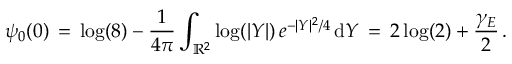<formula> <loc_0><loc_0><loc_500><loc_500>\psi _ { 0 } ( 0 ) \, = \, \log ( 8 ) - \frac { 1 } { 4 \pi } \int _ { \mathbb { R } ^ { 2 } } \log ( | Y | ) \, e ^ { - | Y | ^ { 2 } / 4 } \, d Y \, = \, 2 \log ( 2 ) + \frac { \gamma _ { E } } { 2 } \, .</formula> 